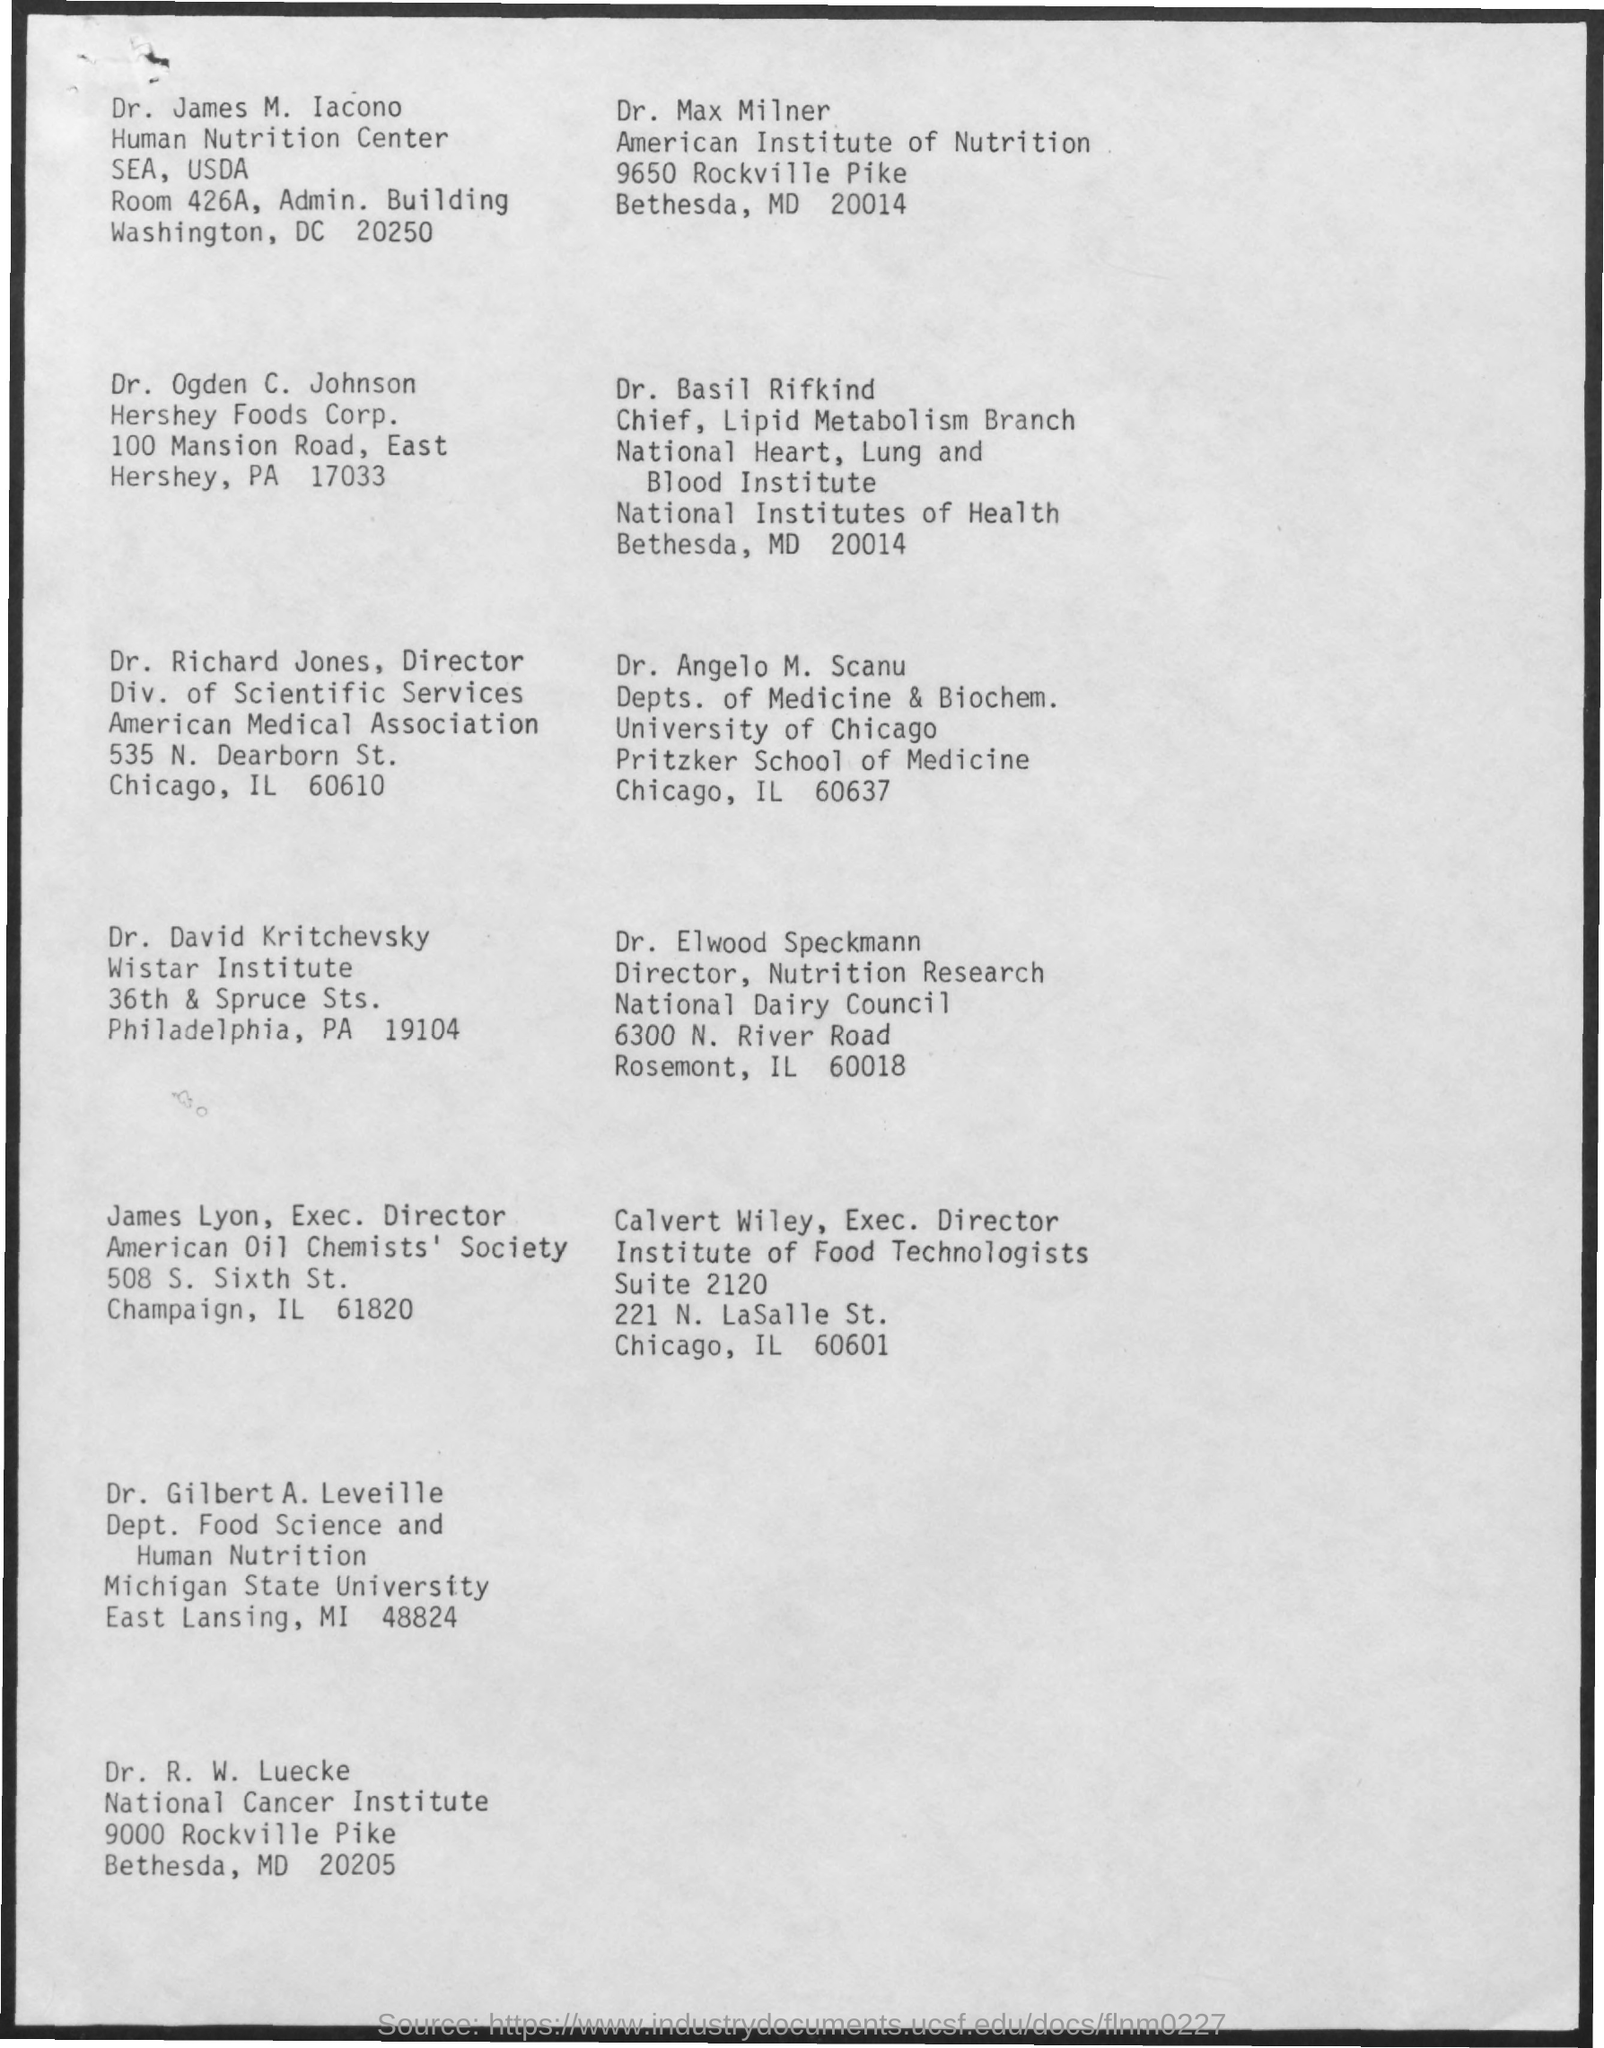Who is the Executive Director of the Institute of Food Technologists?
Make the answer very short. Calvert Wiley. What is the designation of Richard Jones?
Ensure brevity in your answer.  Director. What is the designation of Basil Rifkind?
Provide a short and direct response. Chief, lipid metabolism branch. What is the designation of Elwood Speckmann?
Provide a succinct answer. Director, nutrition research. 